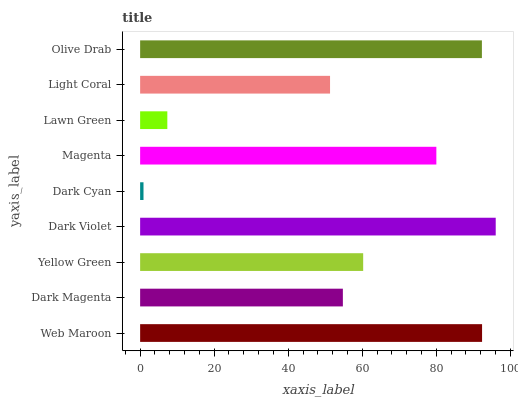Is Dark Cyan the minimum?
Answer yes or no. Yes. Is Dark Violet the maximum?
Answer yes or no. Yes. Is Dark Magenta the minimum?
Answer yes or no. No. Is Dark Magenta the maximum?
Answer yes or no. No. Is Web Maroon greater than Dark Magenta?
Answer yes or no. Yes. Is Dark Magenta less than Web Maroon?
Answer yes or no. Yes. Is Dark Magenta greater than Web Maroon?
Answer yes or no. No. Is Web Maroon less than Dark Magenta?
Answer yes or no. No. Is Yellow Green the high median?
Answer yes or no. Yes. Is Yellow Green the low median?
Answer yes or no. Yes. Is Magenta the high median?
Answer yes or no. No. Is Light Coral the low median?
Answer yes or no. No. 